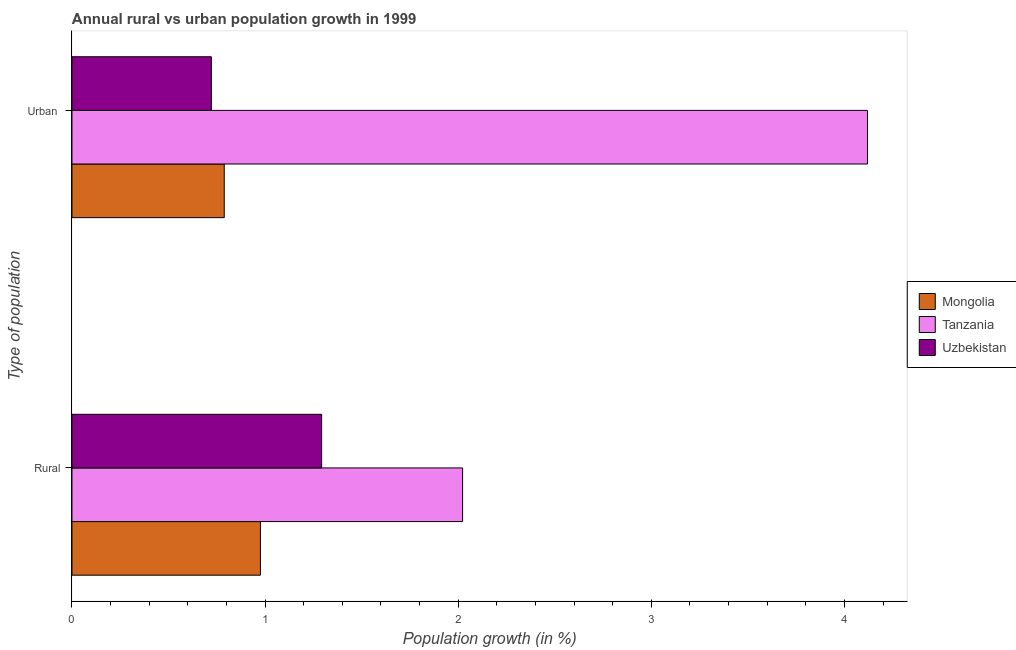How many different coloured bars are there?
Offer a terse response. 3. Are the number of bars on each tick of the Y-axis equal?
Your answer should be very brief. Yes. How many bars are there on the 1st tick from the bottom?
Provide a short and direct response. 3. What is the label of the 1st group of bars from the top?
Your response must be concise. Urban . What is the urban population growth in Mongolia?
Provide a succinct answer. 0.79. Across all countries, what is the maximum urban population growth?
Provide a short and direct response. 4.12. Across all countries, what is the minimum rural population growth?
Provide a succinct answer. 0.98. In which country was the rural population growth maximum?
Your response must be concise. Tanzania. In which country was the rural population growth minimum?
Provide a succinct answer. Mongolia. What is the total urban population growth in the graph?
Ensure brevity in your answer.  5.63. What is the difference between the rural population growth in Mongolia and that in Tanzania?
Make the answer very short. -1.05. What is the difference between the urban population growth in Tanzania and the rural population growth in Uzbekistan?
Keep it short and to the point. 2.83. What is the average urban population growth per country?
Offer a terse response. 1.88. What is the difference between the urban population growth and rural population growth in Mongolia?
Your answer should be compact. -0.19. In how many countries, is the rural population growth greater than 3.6 %?
Give a very brief answer. 0. What is the ratio of the urban population growth in Tanzania to that in Uzbekistan?
Ensure brevity in your answer.  5.71. Is the rural population growth in Tanzania less than that in Uzbekistan?
Your response must be concise. No. What does the 1st bar from the top in Rural represents?
Your answer should be compact. Uzbekistan. What does the 3rd bar from the bottom in Urban  represents?
Keep it short and to the point. Uzbekistan. How many bars are there?
Offer a very short reply. 6. Are all the bars in the graph horizontal?
Offer a very short reply. Yes. How many countries are there in the graph?
Ensure brevity in your answer.  3. Are the values on the major ticks of X-axis written in scientific E-notation?
Give a very brief answer. No. Does the graph contain any zero values?
Give a very brief answer. No. Does the graph contain grids?
Your answer should be very brief. No. How many legend labels are there?
Your answer should be compact. 3. What is the title of the graph?
Offer a very short reply. Annual rural vs urban population growth in 1999. What is the label or title of the X-axis?
Make the answer very short. Population growth (in %). What is the label or title of the Y-axis?
Offer a terse response. Type of population. What is the Population growth (in %) in Mongolia in Rural?
Provide a succinct answer. 0.98. What is the Population growth (in %) of Tanzania in Rural?
Offer a terse response. 2.02. What is the Population growth (in %) in Uzbekistan in Rural?
Your response must be concise. 1.29. What is the Population growth (in %) in Mongolia in Urban ?
Your response must be concise. 0.79. What is the Population growth (in %) of Tanzania in Urban ?
Your response must be concise. 4.12. What is the Population growth (in %) of Uzbekistan in Urban ?
Make the answer very short. 0.72. Across all Type of population, what is the maximum Population growth (in %) in Mongolia?
Ensure brevity in your answer.  0.98. Across all Type of population, what is the maximum Population growth (in %) of Tanzania?
Keep it short and to the point. 4.12. Across all Type of population, what is the maximum Population growth (in %) of Uzbekistan?
Ensure brevity in your answer.  1.29. Across all Type of population, what is the minimum Population growth (in %) in Mongolia?
Provide a short and direct response. 0.79. Across all Type of population, what is the minimum Population growth (in %) of Tanzania?
Provide a short and direct response. 2.02. Across all Type of population, what is the minimum Population growth (in %) of Uzbekistan?
Offer a terse response. 0.72. What is the total Population growth (in %) of Mongolia in the graph?
Provide a short and direct response. 1.76. What is the total Population growth (in %) in Tanzania in the graph?
Provide a succinct answer. 6.14. What is the total Population growth (in %) of Uzbekistan in the graph?
Ensure brevity in your answer.  2.01. What is the difference between the Population growth (in %) in Mongolia in Rural and that in Urban ?
Your response must be concise. 0.19. What is the difference between the Population growth (in %) of Tanzania in Rural and that in Urban ?
Offer a very short reply. -2.1. What is the difference between the Population growth (in %) in Uzbekistan in Rural and that in Urban ?
Your response must be concise. 0.57. What is the difference between the Population growth (in %) in Mongolia in Rural and the Population growth (in %) in Tanzania in Urban ?
Ensure brevity in your answer.  -3.14. What is the difference between the Population growth (in %) in Mongolia in Rural and the Population growth (in %) in Uzbekistan in Urban ?
Your answer should be compact. 0.25. What is the difference between the Population growth (in %) in Tanzania in Rural and the Population growth (in %) in Uzbekistan in Urban ?
Keep it short and to the point. 1.3. What is the average Population growth (in %) in Mongolia per Type of population?
Your answer should be very brief. 0.88. What is the average Population growth (in %) of Tanzania per Type of population?
Offer a terse response. 3.07. What is the average Population growth (in %) in Uzbekistan per Type of population?
Offer a terse response. 1.01. What is the difference between the Population growth (in %) of Mongolia and Population growth (in %) of Tanzania in Rural?
Give a very brief answer. -1.05. What is the difference between the Population growth (in %) in Mongolia and Population growth (in %) in Uzbekistan in Rural?
Ensure brevity in your answer.  -0.32. What is the difference between the Population growth (in %) of Tanzania and Population growth (in %) of Uzbekistan in Rural?
Give a very brief answer. 0.73. What is the difference between the Population growth (in %) of Mongolia and Population growth (in %) of Tanzania in Urban ?
Offer a very short reply. -3.33. What is the difference between the Population growth (in %) in Mongolia and Population growth (in %) in Uzbekistan in Urban ?
Your answer should be very brief. 0.07. What is the difference between the Population growth (in %) of Tanzania and Population growth (in %) of Uzbekistan in Urban ?
Ensure brevity in your answer.  3.4. What is the ratio of the Population growth (in %) of Mongolia in Rural to that in Urban ?
Offer a very short reply. 1.24. What is the ratio of the Population growth (in %) in Tanzania in Rural to that in Urban ?
Provide a succinct answer. 0.49. What is the ratio of the Population growth (in %) in Uzbekistan in Rural to that in Urban ?
Your answer should be very brief. 1.79. What is the difference between the highest and the second highest Population growth (in %) in Mongolia?
Ensure brevity in your answer.  0.19. What is the difference between the highest and the second highest Population growth (in %) of Tanzania?
Give a very brief answer. 2.1. What is the difference between the highest and the second highest Population growth (in %) of Uzbekistan?
Your answer should be very brief. 0.57. What is the difference between the highest and the lowest Population growth (in %) in Mongolia?
Your answer should be compact. 0.19. What is the difference between the highest and the lowest Population growth (in %) of Tanzania?
Ensure brevity in your answer.  2.1. What is the difference between the highest and the lowest Population growth (in %) in Uzbekistan?
Offer a very short reply. 0.57. 